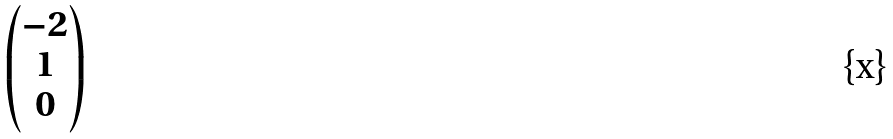<formula> <loc_0><loc_0><loc_500><loc_500>\begin{pmatrix} - 2 \\ 1 \\ 0 \end{pmatrix}</formula> 